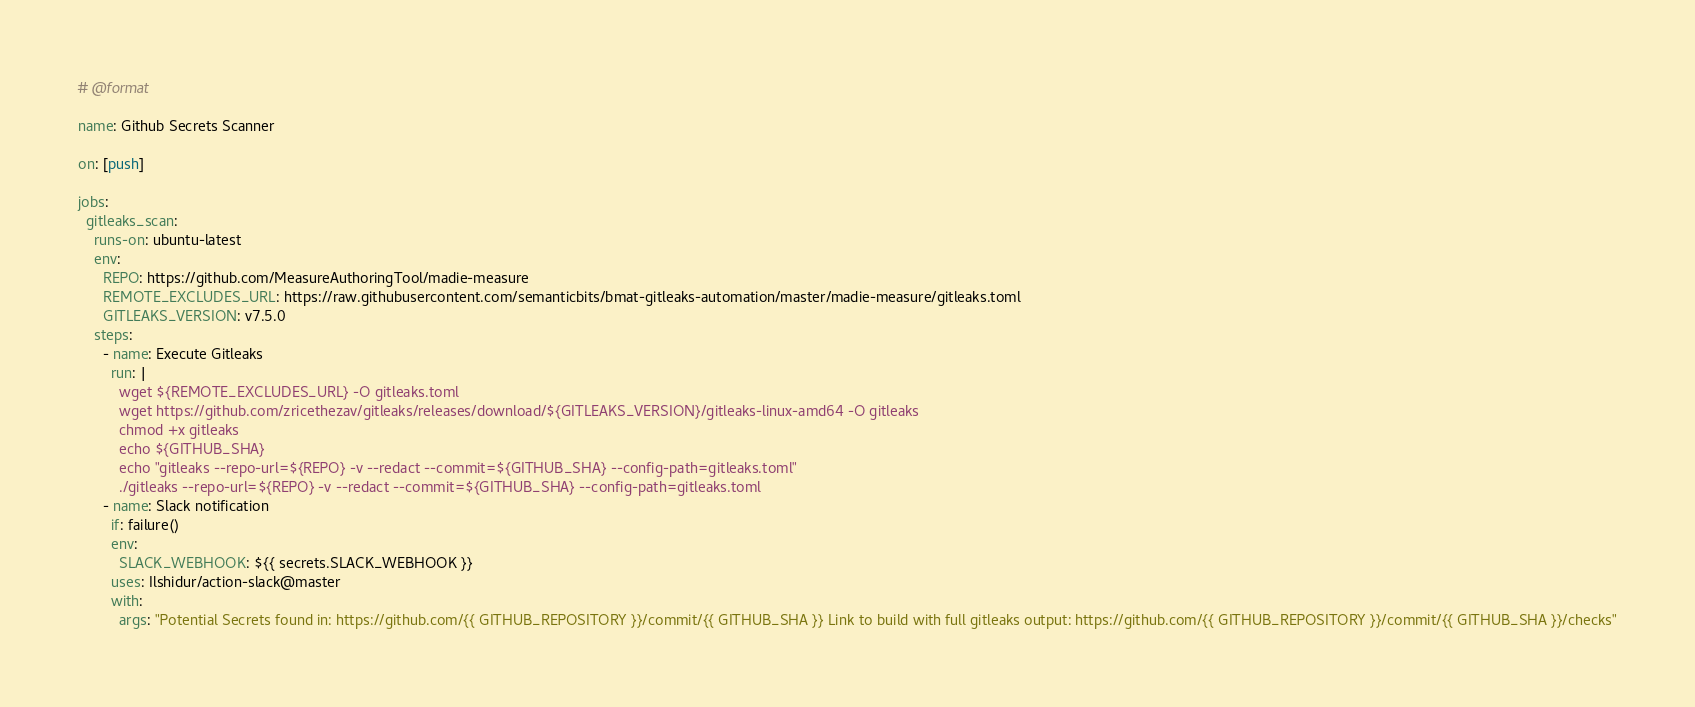<code> <loc_0><loc_0><loc_500><loc_500><_YAML_># @format

name: Github Secrets Scanner

on: [push]

jobs:
  gitleaks_scan:
    runs-on: ubuntu-latest
    env:
      REPO: https://github.com/MeasureAuthoringTool/madie-measure
      REMOTE_EXCLUDES_URL: https://raw.githubusercontent.com/semanticbits/bmat-gitleaks-automation/master/madie-measure/gitleaks.toml
      GITLEAKS_VERSION: v7.5.0
    steps:
      - name: Execute Gitleaks
        run: |
          wget ${REMOTE_EXCLUDES_URL} -O gitleaks.toml
          wget https://github.com/zricethezav/gitleaks/releases/download/${GITLEAKS_VERSION}/gitleaks-linux-amd64 -O gitleaks
          chmod +x gitleaks
          echo ${GITHUB_SHA}
          echo "gitleaks --repo-url=${REPO} -v --redact --commit=${GITHUB_SHA} --config-path=gitleaks.toml"
          ./gitleaks --repo-url=${REPO} -v --redact --commit=${GITHUB_SHA} --config-path=gitleaks.toml
      - name: Slack notification
        if: failure()
        env:
          SLACK_WEBHOOK: ${{ secrets.SLACK_WEBHOOK }}
        uses: Ilshidur/action-slack@master
        with:
          args: "Potential Secrets found in: https://github.com/{{ GITHUB_REPOSITORY }}/commit/{{ GITHUB_SHA }} Link to build with full gitleaks output: https://github.com/{{ GITHUB_REPOSITORY }}/commit/{{ GITHUB_SHA }}/checks"
</code> 